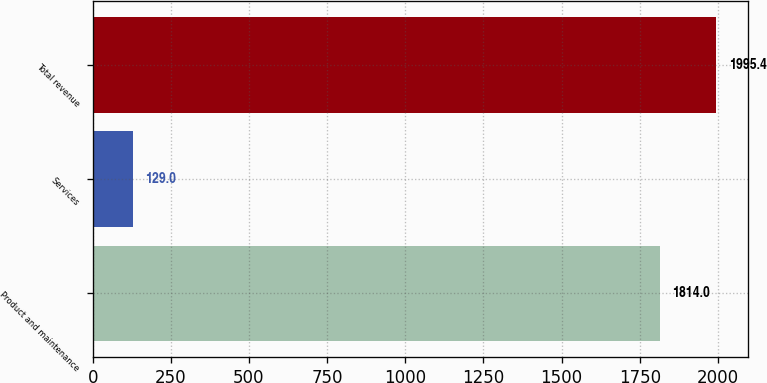Convert chart to OTSL. <chart><loc_0><loc_0><loc_500><loc_500><bar_chart><fcel>Product and maintenance<fcel>Services<fcel>Total revenue<nl><fcel>1814<fcel>129<fcel>1995.4<nl></chart> 